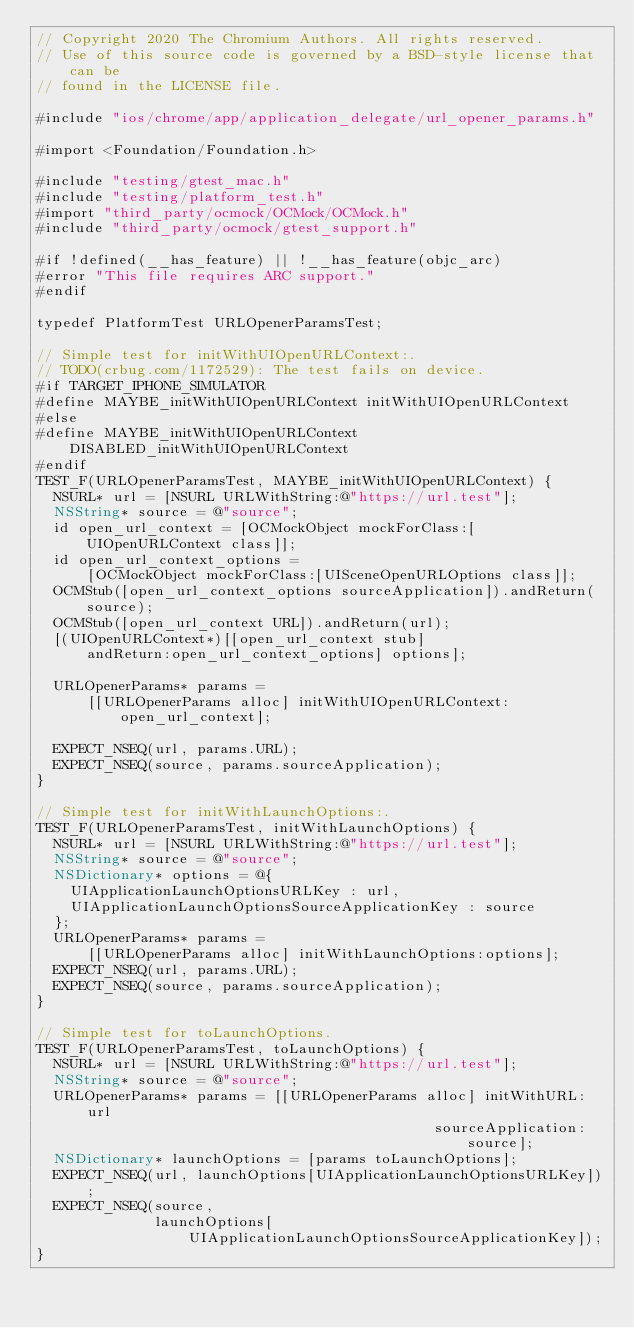<code> <loc_0><loc_0><loc_500><loc_500><_ObjectiveC_>// Copyright 2020 The Chromium Authors. All rights reserved.
// Use of this source code is governed by a BSD-style license that can be
// found in the LICENSE file.

#include "ios/chrome/app/application_delegate/url_opener_params.h"

#import <Foundation/Foundation.h>

#include "testing/gtest_mac.h"
#include "testing/platform_test.h"
#import "third_party/ocmock/OCMock/OCMock.h"
#include "third_party/ocmock/gtest_support.h"

#if !defined(__has_feature) || !__has_feature(objc_arc)
#error "This file requires ARC support."
#endif

typedef PlatformTest URLOpenerParamsTest;

// Simple test for initWithUIOpenURLContext:.
// TODO(crbug.com/1172529): The test fails on device.
#if TARGET_IPHONE_SIMULATOR
#define MAYBE_initWithUIOpenURLContext initWithUIOpenURLContext
#else
#define MAYBE_initWithUIOpenURLContext DISABLED_initWithUIOpenURLContext
#endif
TEST_F(URLOpenerParamsTest, MAYBE_initWithUIOpenURLContext) {
  NSURL* url = [NSURL URLWithString:@"https://url.test"];
  NSString* source = @"source";
  id open_url_context = [OCMockObject mockForClass:[UIOpenURLContext class]];
  id open_url_context_options =
      [OCMockObject mockForClass:[UISceneOpenURLOptions class]];
  OCMStub([open_url_context_options sourceApplication]).andReturn(source);
  OCMStub([open_url_context URL]).andReturn(url);
  [(UIOpenURLContext*)[[open_url_context stub]
      andReturn:open_url_context_options] options];

  URLOpenerParams* params =
      [[URLOpenerParams alloc] initWithUIOpenURLContext:open_url_context];

  EXPECT_NSEQ(url, params.URL);
  EXPECT_NSEQ(source, params.sourceApplication);
}

// Simple test for initWithLaunchOptions:.
TEST_F(URLOpenerParamsTest, initWithLaunchOptions) {
  NSURL* url = [NSURL URLWithString:@"https://url.test"];
  NSString* source = @"source";
  NSDictionary* options = @{
    UIApplicationLaunchOptionsURLKey : url,
    UIApplicationLaunchOptionsSourceApplicationKey : source
  };
  URLOpenerParams* params =
      [[URLOpenerParams alloc] initWithLaunchOptions:options];
  EXPECT_NSEQ(url, params.URL);
  EXPECT_NSEQ(source, params.sourceApplication);
}

// Simple test for toLaunchOptions.
TEST_F(URLOpenerParamsTest, toLaunchOptions) {
  NSURL* url = [NSURL URLWithString:@"https://url.test"];
  NSString* source = @"source";
  URLOpenerParams* params = [[URLOpenerParams alloc] initWithURL:url
                                               sourceApplication:source];
  NSDictionary* launchOptions = [params toLaunchOptions];
  EXPECT_NSEQ(url, launchOptions[UIApplicationLaunchOptionsURLKey]);
  EXPECT_NSEQ(source,
              launchOptions[UIApplicationLaunchOptionsSourceApplicationKey]);
}
</code> 